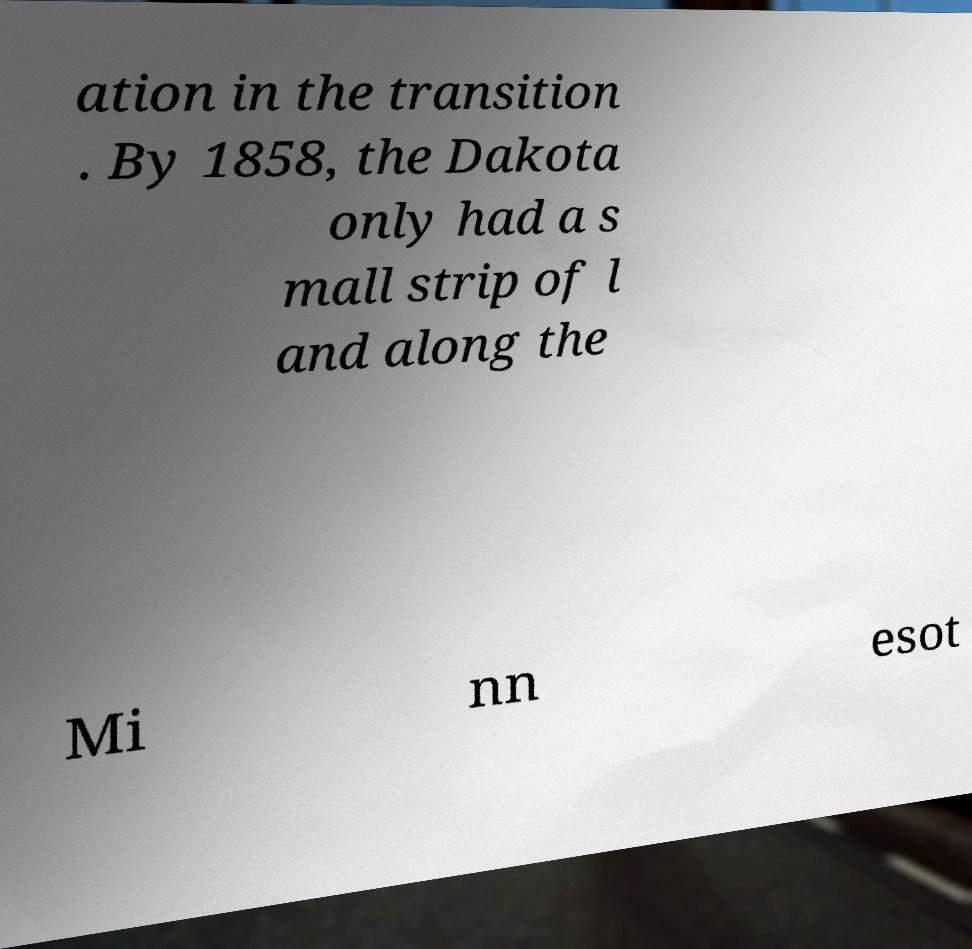Can you read and provide the text displayed in the image?This photo seems to have some interesting text. Can you extract and type it out for me? ation in the transition . By 1858, the Dakota only had a s mall strip of l and along the Mi nn esot 